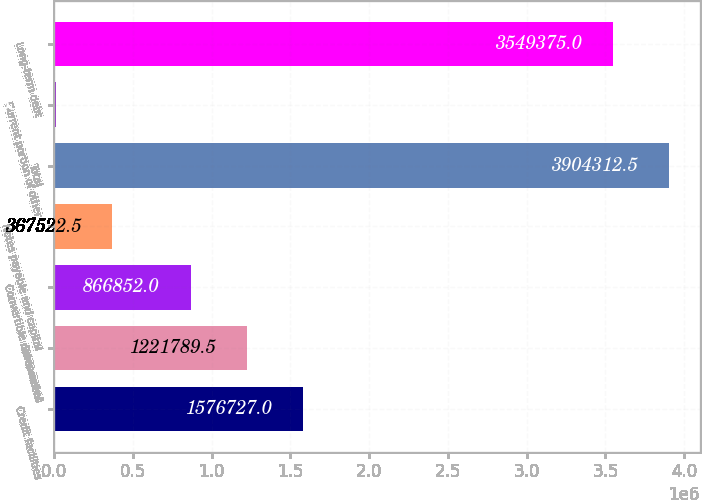Convert chart to OTSL. <chart><loc_0><loc_0><loc_500><loc_500><bar_chart><fcel>Credit facilities<fcel>Seniornotes<fcel>Convertible notes net of<fcel>Notes payable and capital<fcel>Total<fcel>Current portion of other<fcel>Long-term debt<nl><fcel>1.57673e+06<fcel>1.22179e+06<fcel>866852<fcel>367522<fcel>3.90431e+06<fcel>12585<fcel>3.54938e+06<nl></chart> 